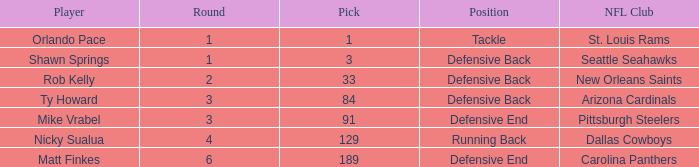What is the lowest pick that has arizona cardinals as the NFL club? 84.0. 